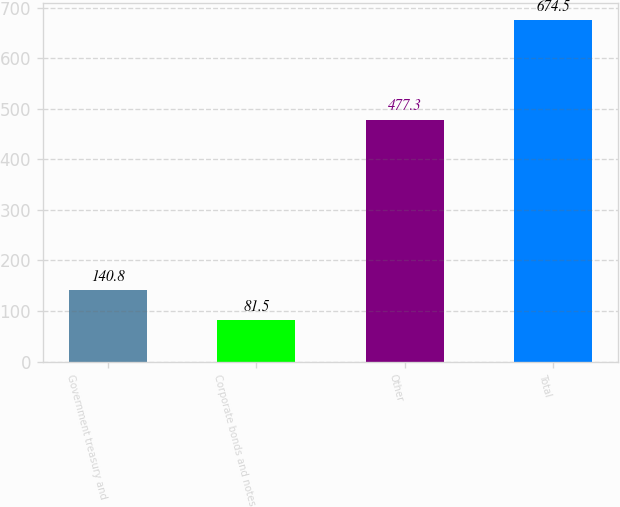<chart> <loc_0><loc_0><loc_500><loc_500><bar_chart><fcel>Government treasury and<fcel>Corporate bonds and notes<fcel>Other<fcel>Total<nl><fcel>140.8<fcel>81.5<fcel>477.3<fcel>674.5<nl></chart> 